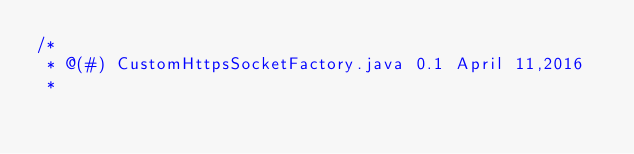<code> <loc_0><loc_0><loc_500><loc_500><_Java_>/*
 * @(#) CustomHttpsSocketFactory.java 0.1 April 11,2016
 *</code> 